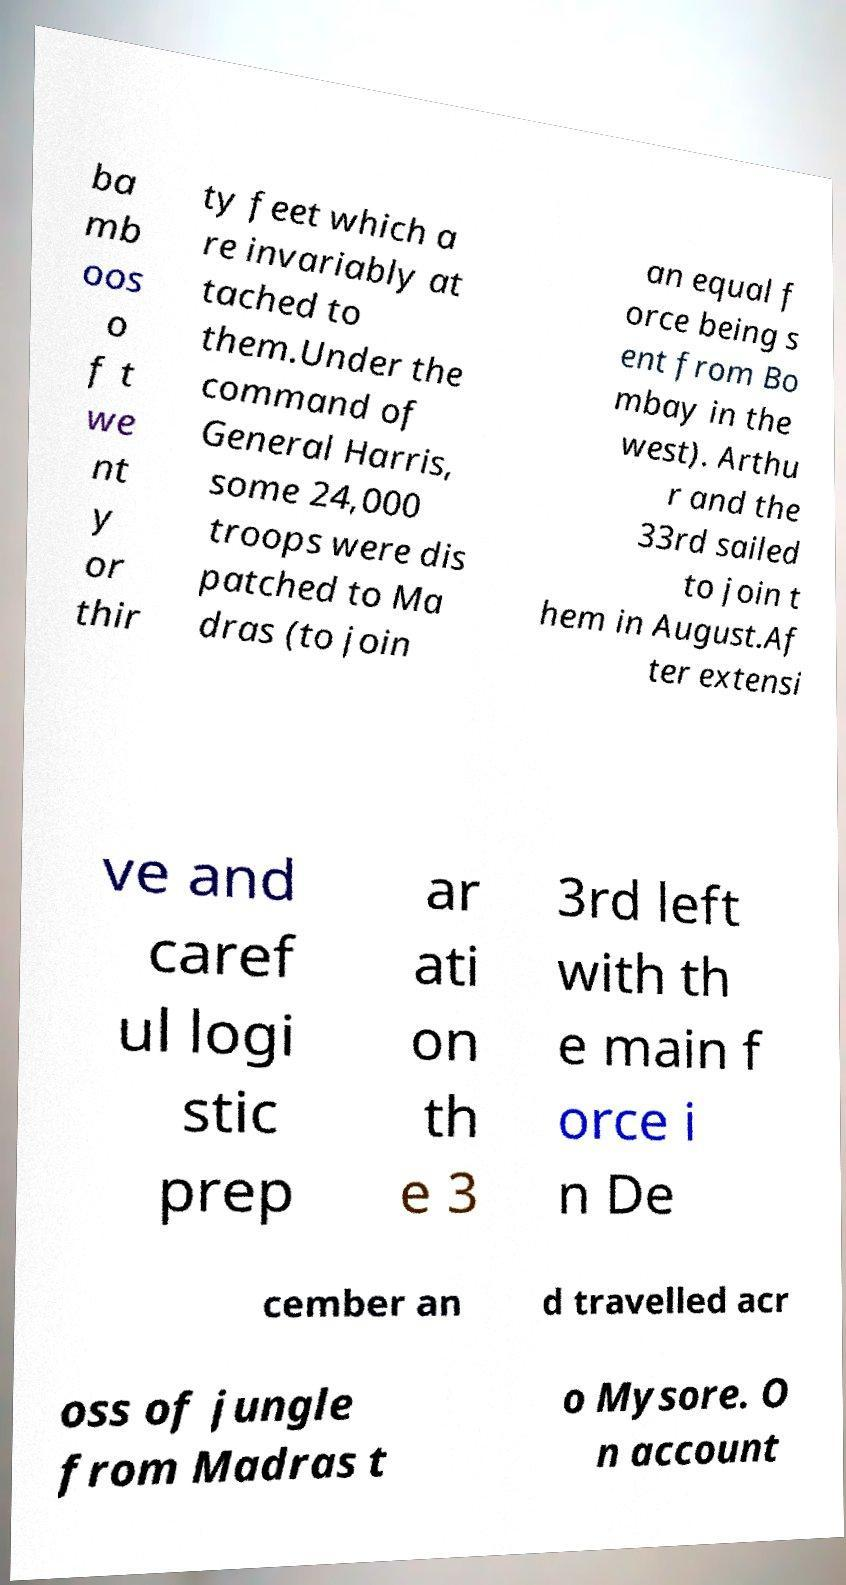I need the written content from this picture converted into text. Can you do that? ba mb oos o f t we nt y or thir ty feet which a re invariably at tached to them.Under the command of General Harris, some 24,000 troops were dis patched to Ma dras (to join an equal f orce being s ent from Bo mbay in the west). Arthu r and the 33rd sailed to join t hem in August.Af ter extensi ve and caref ul logi stic prep ar ati on th e 3 3rd left with th e main f orce i n De cember an d travelled acr oss of jungle from Madras t o Mysore. O n account 